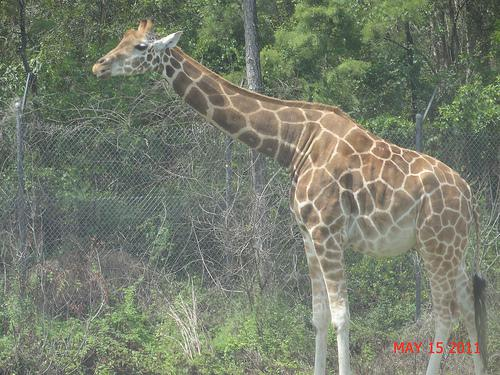Question: what side of the giraffe do we see?
Choices:
A. Front.
B. Right side.
C. Left side.
D. Back side.
Answer with the letter. Answer: C Question: what material is the fence?
Choices:
A. Metal.
B. Wood.
C. Vinyl.
D. Wire.
Answer with the letter. Answer: A Question: how many giraffes are in the photo?
Choices:
A. Two.
B. Three.
C. Four.
D. One.
Answer with the letter. Answer: D Question: what date is on the photo?
Choices:
A. May 15, 2010.
B. May 15, 2012.
C. May 15, 2011.
D. May 15, 2009.
Answer with the letter. Answer: C Question: what is behind the giraffe among the trees?
Choices:
A. A zebra.
B. Safari trucks.
C. Fence.
D. Birds.
Answer with the letter. Answer: C Question: when was the photo taken?
Choices:
A. At night.
B. Early in the morning.
C. In the daytime.
D. Sunset.
Answer with the letter. Answer: C Question: how many birds are in the photo?
Choices:
A. One.
B. Two.
C. Three.
D. None.
Answer with the letter. Answer: D 